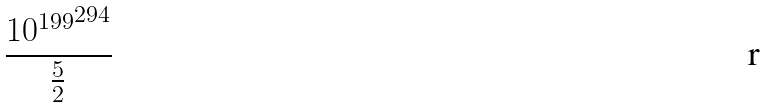Convert formula to latex. <formula><loc_0><loc_0><loc_500><loc_500>\frac { { 1 0 ^ { 1 9 9 } } ^ { 2 9 4 } } { \frac { 5 } { 2 } }</formula> 